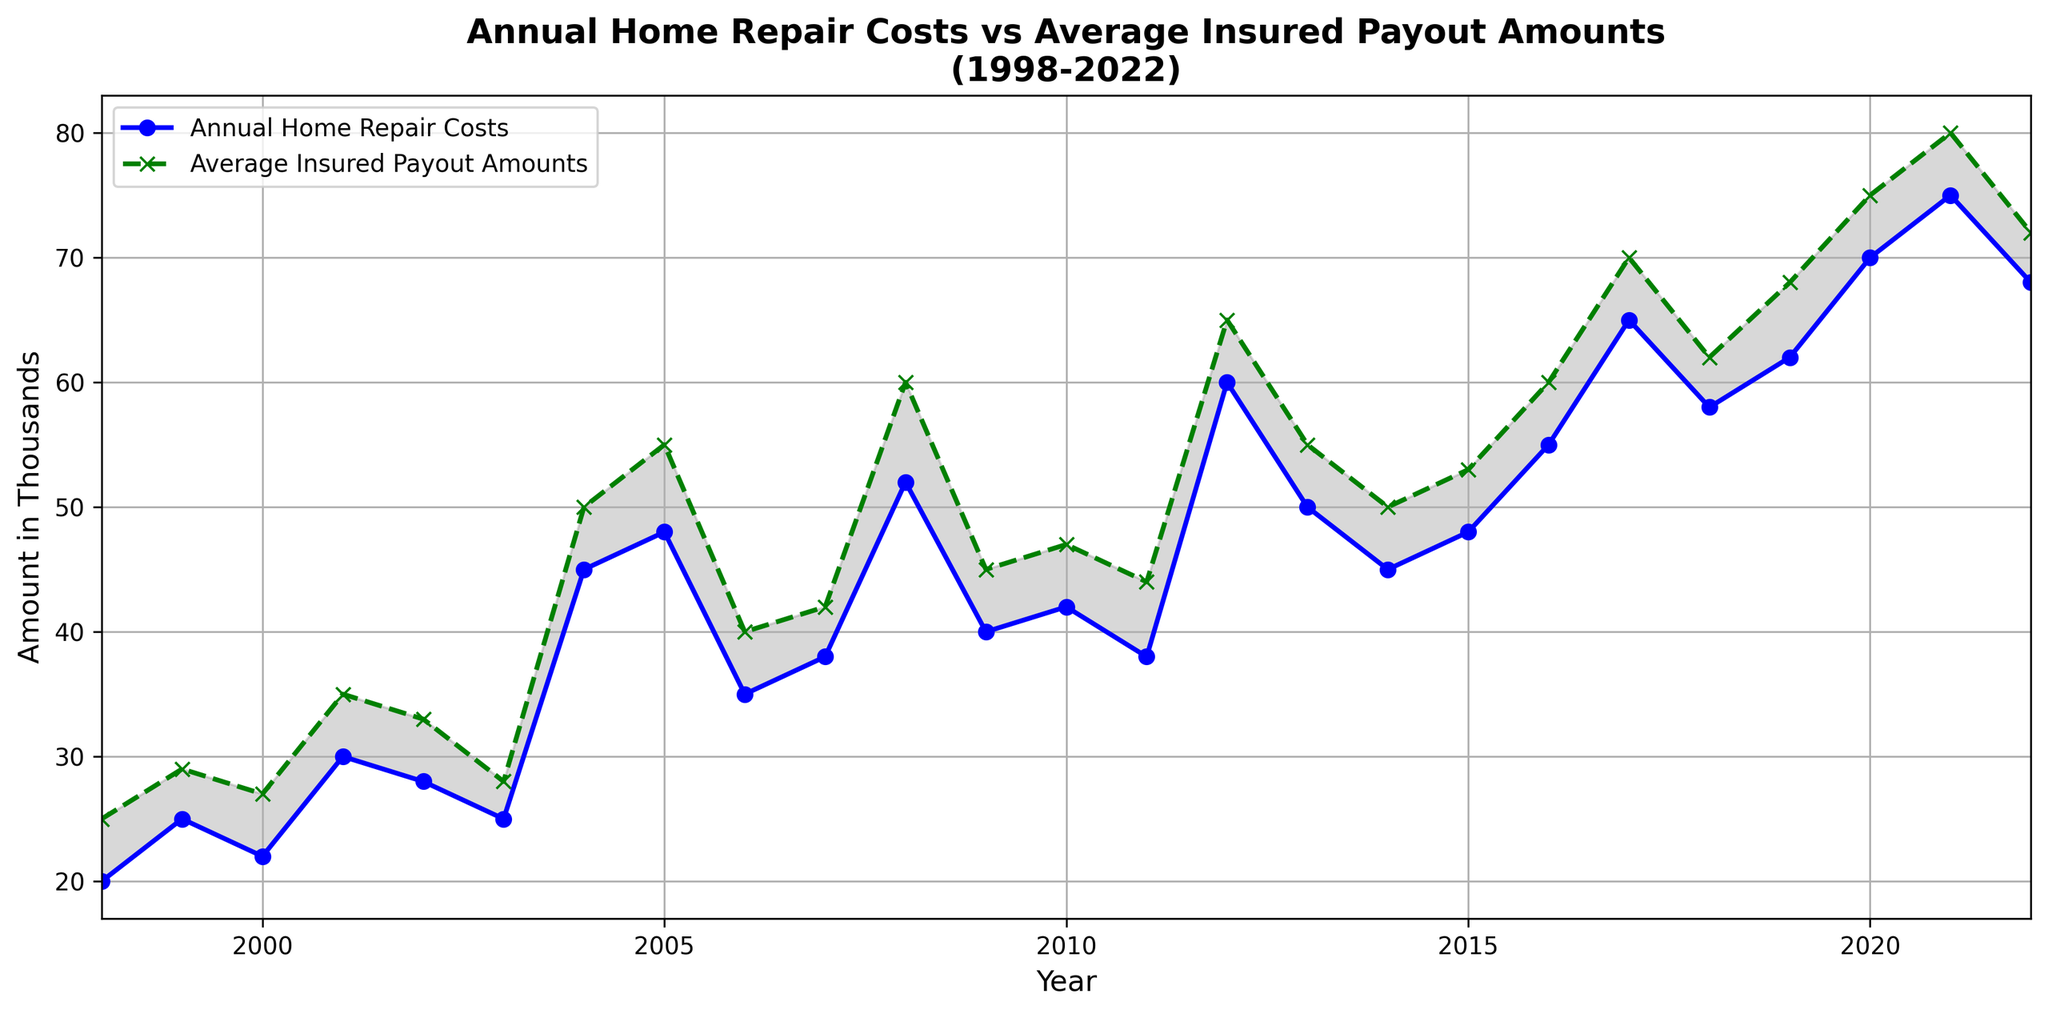When did the annual home repair costs first exceed the average insured payout amounts? Locate the first point where the blue line (Annual Home Repair Costs) is above the green line (Average Insured Payout Amounts). This occurs in 2004.
Answer: 2004 Which year shows the highest difference between annual home repair costs and average insured payout amounts? Look for the year where the vertical distance between the blue and green lines is greatest. The year with the highest difference is 2018.
Answer: 2018 How many years did the home repair costs stay below the insured payouts? Count the number of years where the blue line is below the green line. From 1998 to 2013, this happens in 16 years.
Answer: 16 years In which year do the annual home repair costs and average insured payout amounts visually intersect? Identify the year where the blue and green lines cross each other. They intersect in 2014.
Answer: 2014 What's the average difference between home repair costs and insured payouts from 1998 to 2022? To find the average difference, subtract the annual home repair costs from insured payout amounts for each year, sum these differences, and divide by the number of years (25). (25-20)+(29-25)+(27-22)+(35-30)+(33-28)+(28-25)+(50-45)+(55-48)+(40-35)+(42-38)+(60-52)+(45-40)+(47-42)+(44-38)+(65-60)+(55-50)+(50-45)+(53-48)+(60-55)+(70-65)+(62-58)+(68-62)+(75-70)+(80-75)+(72-68) = 127/25 = 5.08
Answer: 5.08 Which year has the highest insured payout amount and what is the corresponding home repair cost? Locate the peak of the green line and find the corresponding year and the blue line value for that year. The highest payout is in 2021 with a corresponding repair cost of 75.
Answer: 2021, 75 Are there more years where home repair costs are higher than insured payouts or vice versa? Compare the total number of years where the blue line is above the green line and where it is below. There are more years where the blue line is below the green line (16 years under, 9 years over).
Answer: More years where repair costs are lower than insured payouts What is the general trend in annual home repair costs from 1998 to 2022? Observe the progression of the blue line from left to right. It generally trends upward with some fluctuations.
Answer: Upward trend During which years did the home repair costs increase consecutively and by how much? Identify years where the blue line continuously rises year-over-year. From 2010 to 2012, the values increased consecutively: 40, 42, 38, 60. The increase is 60 - 42 = 18.
Answer: 2010-2012, by 18 What was the difference between the highest recorded home repair cost and the lowest recorded home repair cost? Find the highest and lowest points on the blue line. The highest is in 2021 (75) and the lowest in 1998 (20). The difference is 75 - 20 = 55.
Answer: 55 